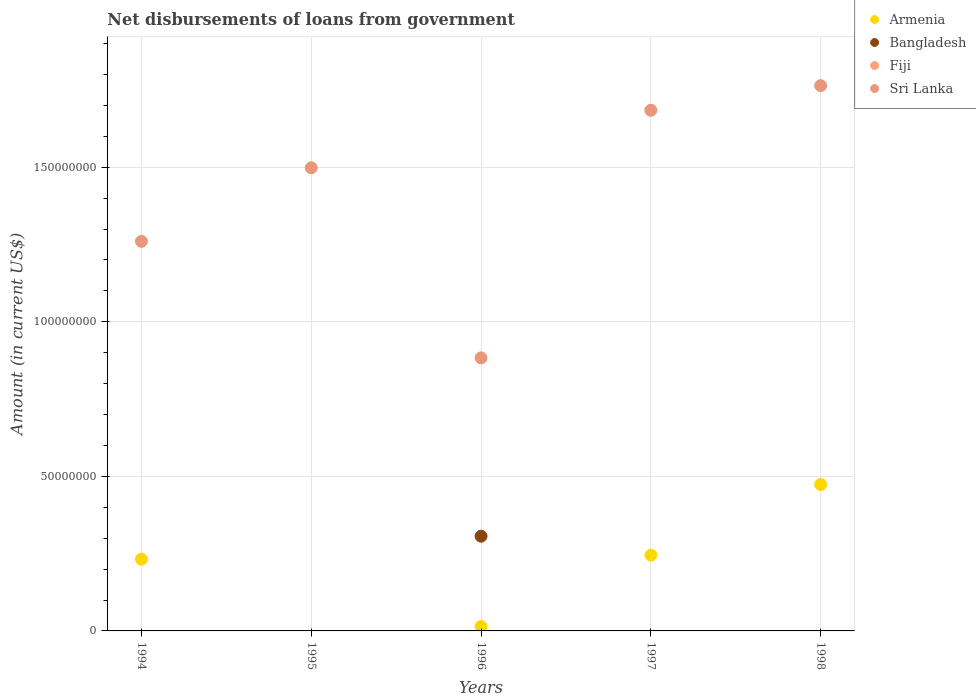Is the number of dotlines equal to the number of legend labels?
Give a very brief answer. No. What is the amount of loan disbursed from government in Sri Lanka in 1998?
Offer a very short reply. 1.76e+08. Across all years, what is the maximum amount of loan disbursed from government in Sri Lanka?
Your answer should be very brief. 1.76e+08. In which year was the amount of loan disbursed from government in Sri Lanka maximum?
Make the answer very short. 1998. What is the total amount of loan disbursed from government in Sri Lanka in the graph?
Your answer should be very brief. 7.09e+08. What is the difference between the amount of loan disbursed from government in Sri Lanka in 1995 and that in 1997?
Your answer should be very brief. -1.86e+07. What is the difference between the amount of loan disbursed from government in Fiji in 1997 and the amount of loan disbursed from government in Bangladesh in 1995?
Provide a short and direct response. 0. What is the average amount of loan disbursed from government in Sri Lanka per year?
Offer a very short reply. 1.42e+08. In the year 1998, what is the difference between the amount of loan disbursed from government in Armenia and amount of loan disbursed from government in Sri Lanka?
Offer a terse response. -1.29e+08. Is the amount of loan disbursed from government in Armenia in 1994 less than that in 1996?
Offer a very short reply. No. Is the difference between the amount of loan disbursed from government in Armenia in 1996 and 1997 greater than the difference between the amount of loan disbursed from government in Sri Lanka in 1996 and 1997?
Give a very brief answer. Yes. What is the difference between the highest and the second highest amount of loan disbursed from government in Armenia?
Your answer should be very brief. 2.28e+07. What is the difference between the highest and the lowest amount of loan disbursed from government in Sri Lanka?
Ensure brevity in your answer.  8.81e+07. Is it the case that in every year, the sum of the amount of loan disbursed from government in Bangladesh and amount of loan disbursed from government in Fiji  is greater than the sum of amount of loan disbursed from government in Sri Lanka and amount of loan disbursed from government in Armenia?
Your answer should be very brief. No. Is it the case that in every year, the sum of the amount of loan disbursed from government in Sri Lanka and amount of loan disbursed from government in Fiji  is greater than the amount of loan disbursed from government in Bangladesh?
Give a very brief answer. Yes. Does the amount of loan disbursed from government in Armenia monotonically increase over the years?
Offer a terse response. No. How many years are there in the graph?
Provide a short and direct response. 5. Are the values on the major ticks of Y-axis written in scientific E-notation?
Your response must be concise. No. Does the graph contain any zero values?
Make the answer very short. Yes. How many legend labels are there?
Provide a succinct answer. 4. How are the legend labels stacked?
Your answer should be very brief. Vertical. What is the title of the graph?
Provide a succinct answer. Net disbursements of loans from government. Does "Senegal" appear as one of the legend labels in the graph?
Your answer should be very brief. No. What is the label or title of the X-axis?
Offer a very short reply. Years. What is the label or title of the Y-axis?
Offer a terse response. Amount (in current US$). What is the Amount (in current US$) of Armenia in 1994?
Offer a terse response. 2.32e+07. What is the Amount (in current US$) of Bangladesh in 1994?
Offer a very short reply. 0. What is the Amount (in current US$) in Sri Lanka in 1994?
Your response must be concise. 1.26e+08. What is the Amount (in current US$) of Armenia in 1995?
Provide a short and direct response. 0. What is the Amount (in current US$) of Fiji in 1995?
Keep it short and to the point. 0. What is the Amount (in current US$) in Sri Lanka in 1995?
Offer a terse response. 1.50e+08. What is the Amount (in current US$) of Armenia in 1996?
Your response must be concise. 1.45e+06. What is the Amount (in current US$) in Bangladesh in 1996?
Keep it short and to the point. 3.06e+07. What is the Amount (in current US$) of Fiji in 1996?
Make the answer very short. 0. What is the Amount (in current US$) of Sri Lanka in 1996?
Keep it short and to the point. 8.83e+07. What is the Amount (in current US$) in Armenia in 1997?
Give a very brief answer. 2.45e+07. What is the Amount (in current US$) in Fiji in 1997?
Offer a very short reply. 0. What is the Amount (in current US$) in Sri Lanka in 1997?
Keep it short and to the point. 1.68e+08. What is the Amount (in current US$) in Armenia in 1998?
Keep it short and to the point. 4.74e+07. What is the Amount (in current US$) in Bangladesh in 1998?
Provide a succinct answer. 0. What is the Amount (in current US$) of Sri Lanka in 1998?
Offer a terse response. 1.76e+08. Across all years, what is the maximum Amount (in current US$) of Armenia?
Your answer should be compact. 4.74e+07. Across all years, what is the maximum Amount (in current US$) of Bangladesh?
Offer a very short reply. 3.06e+07. Across all years, what is the maximum Amount (in current US$) of Sri Lanka?
Make the answer very short. 1.76e+08. Across all years, what is the minimum Amount (in current US$) in Bangladesh?
Your response must be concise. 0. Across all years, what is the minimum Amount (in current US$) of Sri Lanka?
Offer a terse response. 8.83e+07. What is the total Amount (in current US$) of Armenia in the graph?
Make the answer very short. 9.66e+07. What is the total Amount (in current US$) in Bangladesh in the graph?
Your response must be concise. 3.06e+07. What is the total Amount (in current US$) of Fiji in the graph?
Your answer should be compact. 0. What is the total Amount (in current US$) of Sri Lanka in the graph?
Give a very brief answer. 7.09e+08. What is the difference between the Amount (in current US$) in Sri Lanka in 1994 and that in 1995?
Ensure brevity in your answer.  -2.38e+07. What is the difference between the Amount (in current US$) of Armenia in 1994 and that in 1996?
Keep it short and to the point. 2.18e+07. What is the difference between the Amount (in current US$) in Sri Lanka in 1994 and that in 1996?
Offer a very short reply. 3.77e+07. What is the difference between the Amount (in current US$) of Armenia in 1994 and that in 1997?
Provide a short and direct response. -1.30e+06. What is the difference between the Amount (in current US$) of Sri Lanka in 1994 and that in 1997?
Provide a succinct answer. -4.24e+07. What is the difference between the Amount (in current US$) of Armenia in 1994 and that in 1998?
Your answer should be compact. -2.41e+07. What is the difference between the Amount (in current US$) in Sri Lanka in 1994 and that in 1998?
Provide a succinct answer. -5.04e+07. What is the difference between the Amount (in current US$) of Sri Lanka in 1995 and that in 1996?
Your answer should be very brief. 6.15e+07. What is the difference between the Amount (in current US$) of Sri Lanka in 1995 and that in 1997?
Your answer should be compact. -1.86e+07. What is the difference between the Amount (in current US$) in Sri Lanka in 1995 and that in 1998?
Your answer should be very brief. -2.66e+07. What is the difference between the Amount (in current US$) in Armenia in 1996 and that in 1997?
Give a very brief answer. -2.31e+07. What is the difference between the Amount (in current US$) in Sri Lanka in 1996 and that in 1997?
Offer a terse response. -8.01e+07. What is the difference between the Amount (in current US$) of Armenia in 1996 and that in 1998?
Give a very brief answer. -4.59e+07. What is the difference between the Amount (in current US$) of Sri Lanka in 1996 and that in 1998?
Offer a very short reply. -8.81e+07. What is the difference between the Amount (in current US$) of Armenia in 1997 and that in 1998?
Offer a very short reply. -2.28e+07. What is the difference between the Amount (in current US$) of Sri Lanka in 1997 and that in 1998?
Give a very brief answer. -7.97e+06. What is the difference between the Amount (in current US$) in Armenia in 1994 and the Amount (in current US$) in Sri Lanka in 1995?
Your response must be concise. -1.27e+08. What is the difference between the Amount (in current US$) in Armenia in 1994 and the Amount (in current US$) in Bangladesh in 1996?
Your answer should be compact. -7.42e+06. What is the difference between the Amount (in current US$) in Armenia in 1994 and the Amount (in current US$) in Sri Lanka in 1996?
Provide a short and direct response. -6.51e+07. What is the difference between the Amount (in current US$) in Armenia in 1994 and the Amount (in current US$) in Sri Lanka in 1997?
Offer a very short reply. -1.45e+08. What is the difference between the Amount (in current US$) in Armenia in 1994 and the Amount (in current US$) in Sri Lanka in 1998?
Make the answer very short. -1.53e+08. What is the difference between the Amount (in current US$) of Armenia in 1996 and the Amount (in current US$) of Sri Lanka in 1997?
Your answer should be very brief. -1.67e+08. What is the difference between the Amount (in current US$) of Bangladesh in 1996 and the Amount (in current US$) of Sri Lanka in 1997?
Offer a very short reply. -1.38e+08. What is the difference between the Amount (in current US$) of Armenia in 1996 and the Amount (in current US$) of Sri Lanka in 1998?
Make the answer very short. -1.75e+08. What is the difference between the Amount (in current US$) of Bangladesh in 1996 and the Amount (in current US$) of Sri Lanka in 1998?
Ensure brevity in your answer.  -1.46e+08. What is the difference between the Amount (in current US$) of Armenia in 1997 and the Amount (in current US$) of Sri Lanka in 1998?
Your response must be concise. -1.52e+08. What is the average Amount (in current US$) in Armenia per year?
Your response must be concise. 1.93e+07. What is the average Amount (in current US$) in Bangladesh per year?
Your answer should be compact. 6.13e+06. What is the average Amount (in current US$) in Sri Lanka per year?
Offer a very short reply. 1.42e+08. In the year 1994, what is the difference between the Amount (in current US$) in Armenia and Amount (in current US$) in Sri Lanka?
Offer a terse response. -1.03e+08. In the year 1996, what is the difference between the Amount (in current US$) of Armenia and Amount (in current US$) of Bangladesh?
Your answer should be very brief. -2.92e+07. In the year 1996, what is the difference between the Amount (in current US$) in Armenia and Amount (in current US$) in Sri Lanka?
Offer a very short reply. -8.69e+07. In the year 1996, what is the difference between the Amount (in current US$) in Bangladesh and Amount (in current US$) in Sri Lanka?
Offer a very short reply. -5.77e+07. In the year 1997, what is the difference between the Amount (in current US$) in Armenia and Amount (in current US$) in Sri Lanka?
Provide a short and direct response. -1.44e+08. In the year 1998, what is the difference between the Amount (in current US$) in Armenia and Amount (in current US$) in Sri Lanka?
Provide a short and direct response. -1.29e+08. What is the ratio of the Amount (in current US$) in Sri Lanka in 1994 to that in 1995?
Keep it short and to the point. 0.84. What is the ratio of the Amount (in current US$) of Armenia in 1994 to that in 1996?
Your response must be concise. 16.04. What is the ratio of the Amount (in current US$) of Sri Lanka in 1994 to that in 1996?
Your answer should be very brief. 1.43. What is the ratio of the Amount (in current US$) of Armenia in 1994 to that in 1997?
Offer a terse response. 0.95. What is the ratio of the Amount (in current US$) in Sri Lanka in 1994 to that in 1997?
Make the answer very short. 0.75. What is the ratio of the Amount (in current US$) of Armenia in 1994 to that in 1998?
Provide a succinct answer. 0.49. What is the ratio of the Amount (in current US$) in Sri Lanka in 1994 to that in 1998?
Offer a terse response. 0.71. What is the ratio of the Amount (in current US$) of Sri Lanka in 1995 to that in 1996?
Provide a succinct answer. 1.7. What is the ratio of the Amount (in current US$) in Sri Lanka in 1995 to that in 1997?
Keep it short and to the point. 0.89. What is the ratio of the Amount (in current US$) in Sri Lanka in 1995 to that in 1998?
Provide a short and direct response. 0.85. What is the ratio of the Amount (in current US$) of Armenia in 1996 to that in 1997?
Your answer should be compact. 0.06. What is the ratio of the Amount (in current US$) of Sri Lanka in 1996 to that in 1997?
Your answer should be compact. 0.52. What is the ratio of the Amount (in current US$) in Armenia in 1996 to that in 1998?
Offer a very short reply. 0.03. What is the ratio of the Amount (in current US$) in Sri Lanka in 1996 to that in 1998?
Your response must be concise. 0.5. What is the ratio of the Amount (in current US$) in Armenia in 1997 to that in 1998?
Offer a terse response. 0.52. What is the ratio of the Amount (in current US$) in Sri Lanka in 1997 to that in 1998?
Your answer should be very brief. 0.95. What is the difference between the highest and the second highest Amount (in current US$) of Armenia?
Provide a succinct answer. 2.28e+07. What is the difference between the highest and the second highest Amount (in current US$) in Sri Lanka?
Offer a very short reply. 7.97e+06. What is the difference between the highest and the lowest Amount (in current US$) of Armenia?
Offer a very short reply. 4.74e+07. What is the difference between the highest and the lowest Amount (in current US$) of Bangladesh?
Make the answer very short. 3.06e+07. What is the difference between the highest and the lowest Amount (in current US$) of Sri Lanka?
Provide a short and direct response. 8.81e+07. 